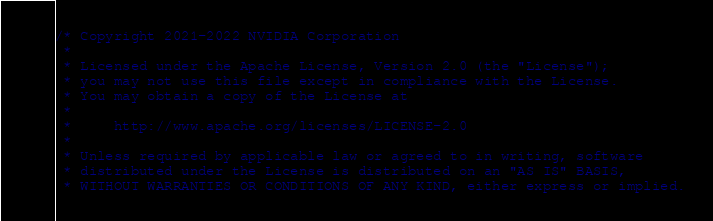<code> <loc_0><loc_0><loc_500><loc_500><_Cuda_>/* Copyright 2021-2022 NVIDIA Corporation
 *
 * Licensed under the Apache License, Version 2.0 (the "License");
 * you may not use this file except in compliance with the License.
 * You may obtain a copy of the License at
 *
 *     http://www.apache.org/licenses/LICENSE-2.0
 *
 * Unless required by applicable law or agreed to in writing, software
 * distributed under the License is distributed on an "AS IS" BASIS,
 * WITHOUT WARRANTIES OR CONDITIONS OF ANY KIND, either express or implied.</code> 